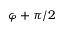<formula> <loc_0><loc_0><loc_500><loc_500>\varphi + \pi / 2</formula> 